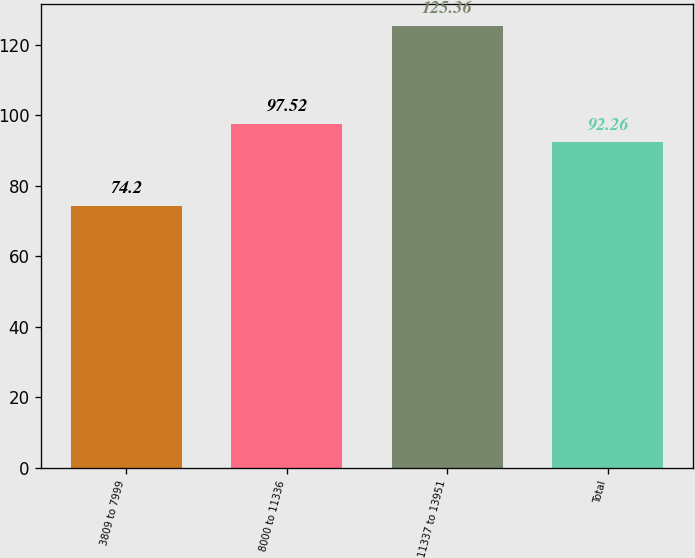Convert chart. <chart><loc_0><loc_0><loc_500><loc_500><bar_chart><fcel>3809 to 7999<fcel>8000 to 11336<fcel>11337 to 13951<fcel>Total<nl><fcel>74.2<fcel>97.52<fcel>125.36<fcel>92.26<nl></chart> 